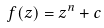<formula> <loc_0><loc_0><loc_500><loc_500>f ( z ) = z ^ { n } + c</formula> 